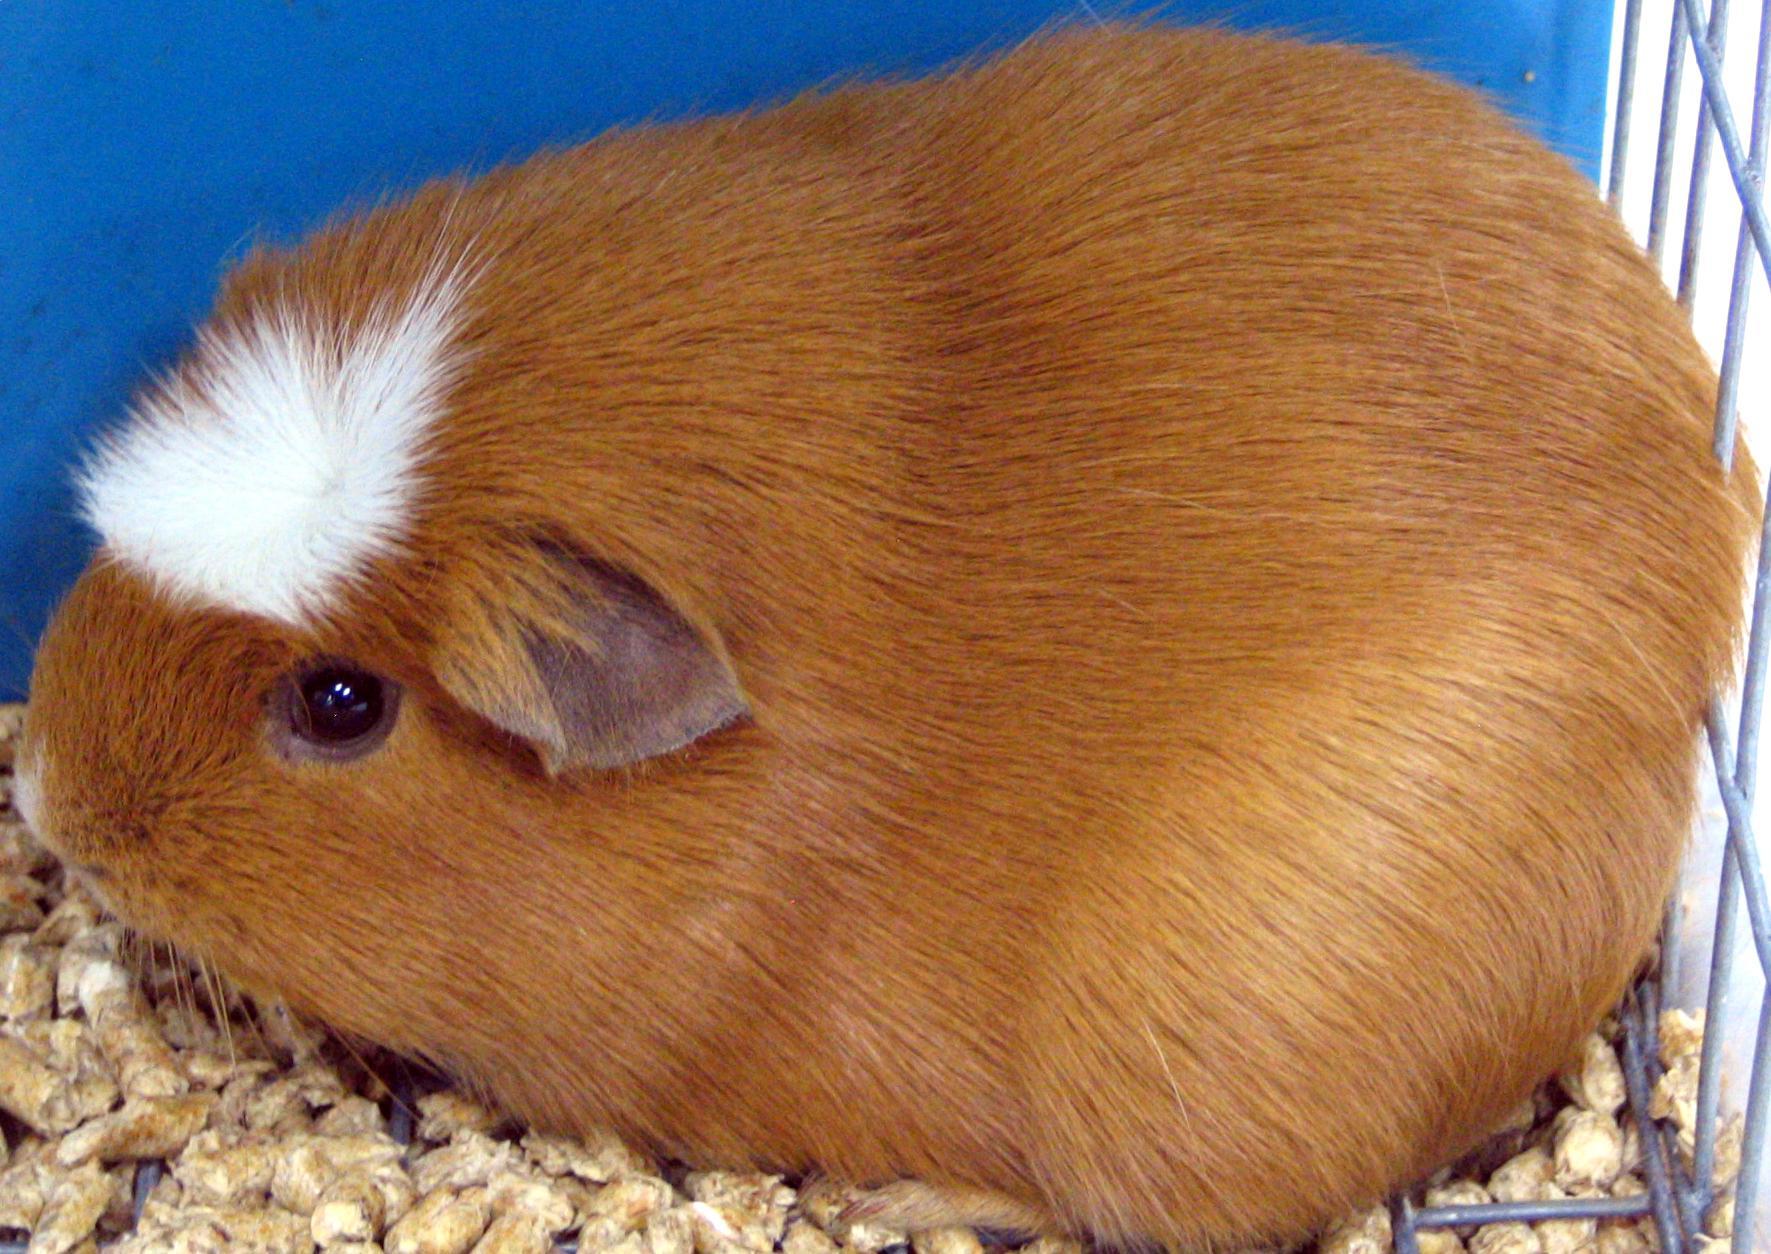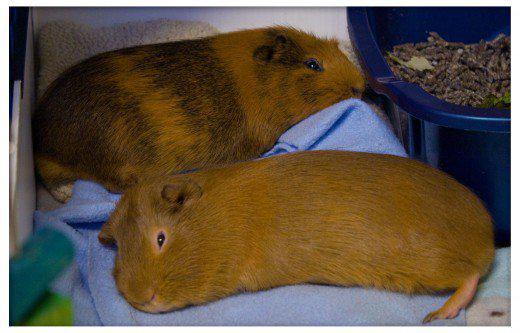The first image is the image on the left, the second image is the image on the right. Considering the images on both sides, is "There are exactly 3 animals." valid? Answer yes or no. Yes. 